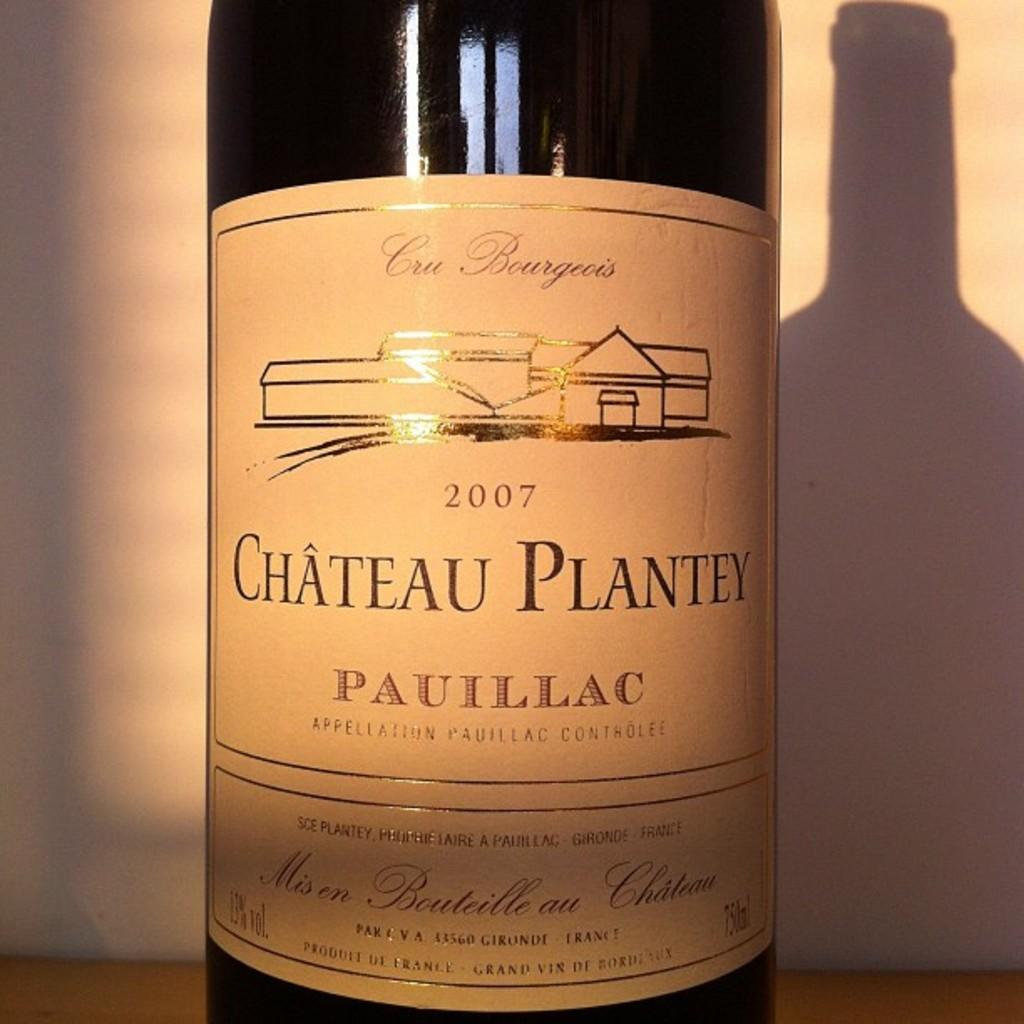<image>
Summarize the visual content of the image. A bottle of wine from Chateau Plantey from 2007. 